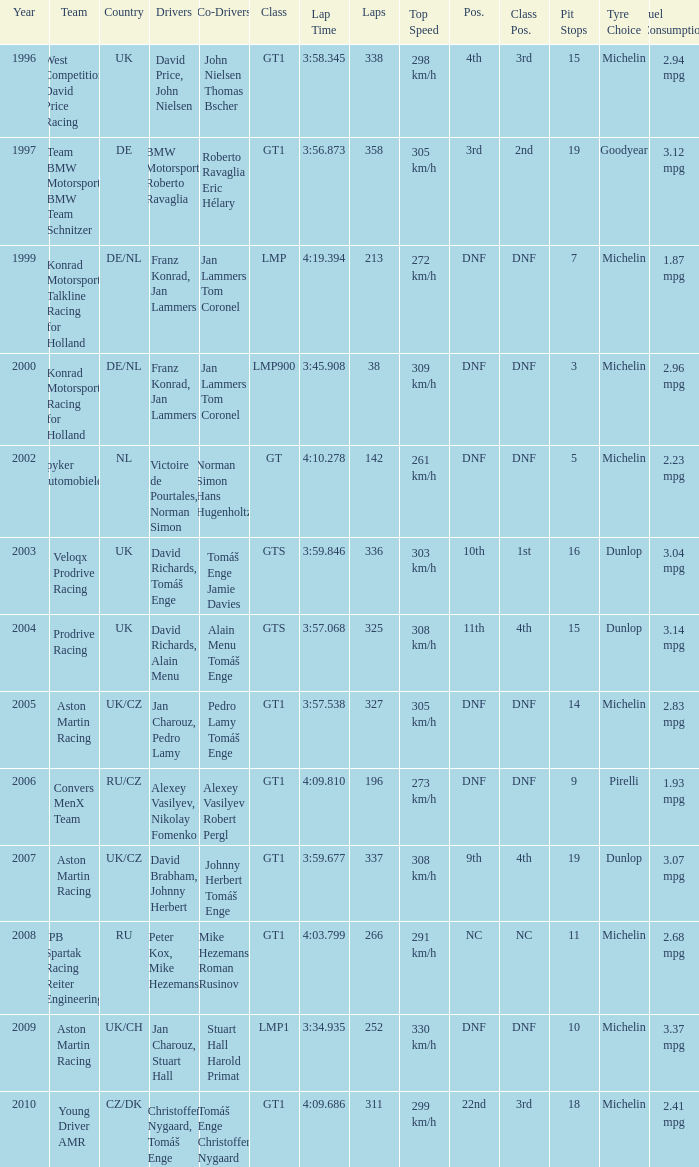In which class had 252 laps and a position of dnf? LMP1. 